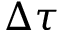Convert formula to latex. <formula><loc_0><loc_0><loc_500><loc_500>\Delta \tau</formula> 